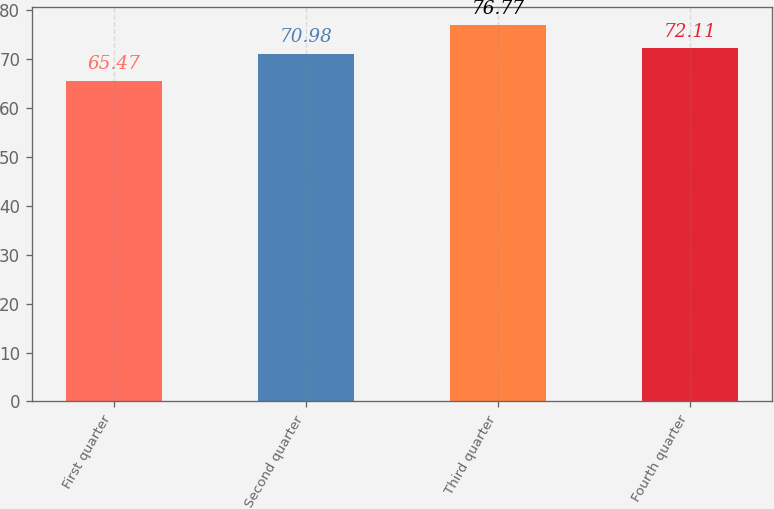Convert chart. <chart><loc_0><loc_0><loc_500><loc_500><bar_chart><fcel>First quarter<fcel>Second quarter<fcel>Third quarter<fcel>Fourth quarter<nl><fcel>65.47<fcel>70.98<fcel>76.77<fcel>72.11<nl></chart> 